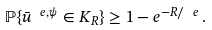Convert formula to latex. <formula><loc_0><loc_0><loc_500><loc_500>\mathbb { P } \{ \bar { u } ^ { \ e , \psi } \in K _ { R } \} \geq 1 - e ^ { - { R } / { \ e } } \, .</formula> 